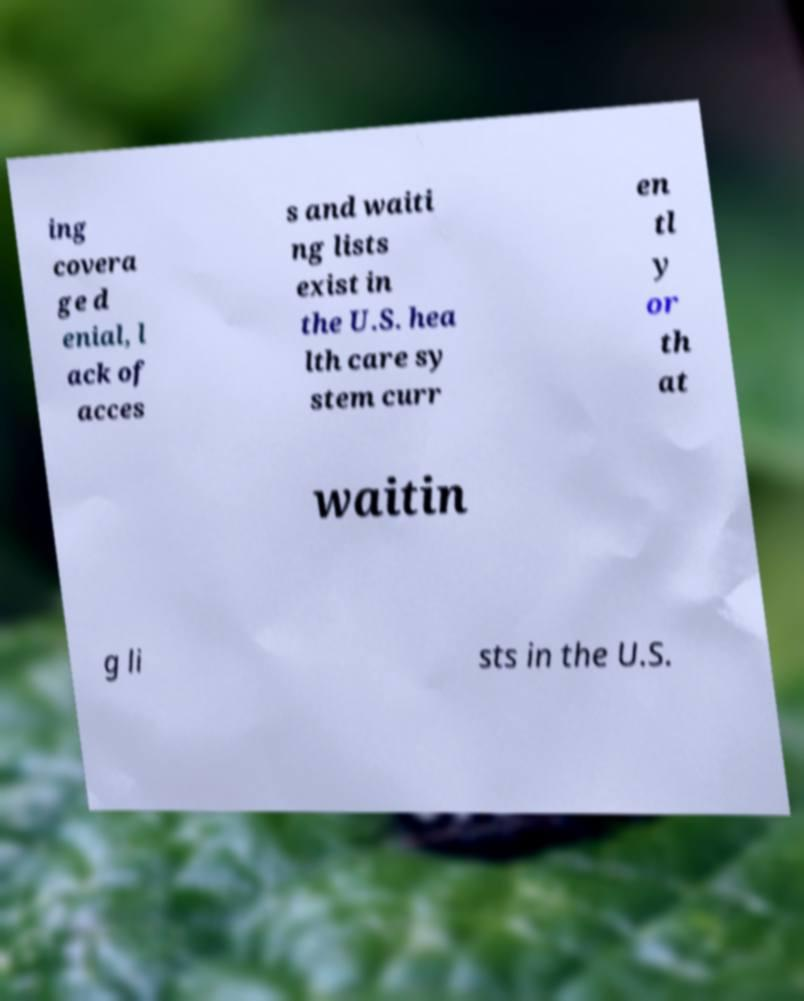For documentation purposes, I need the text within this image transcribed. Could you provide that? ing covera ge d enial, l ack of acces s and waiti ng lists exist in the U.S. hea lth care sy stem curr en tl y or th at waitin g li sts in the U.S. 